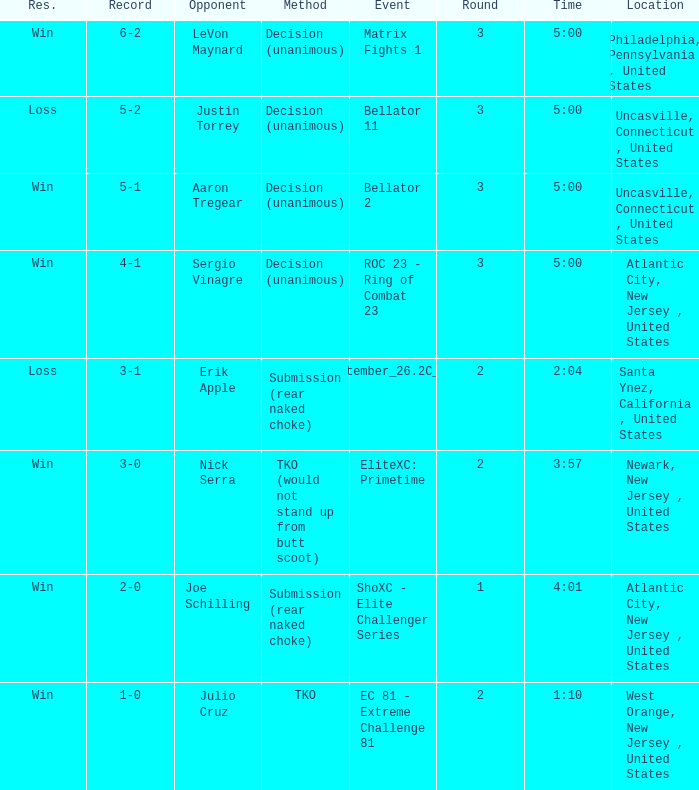Who was the adversary during the tko technique? Julio Cruz. 